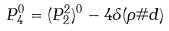<formula> <loc_0><loc_0><loc_500><loc_500>P _ { 4 } ^ { 0 } = ( P _ { 2 } ^ { 2 } ) ^ { 0 } - 4 \delta ( \rho \# d )</formula> 